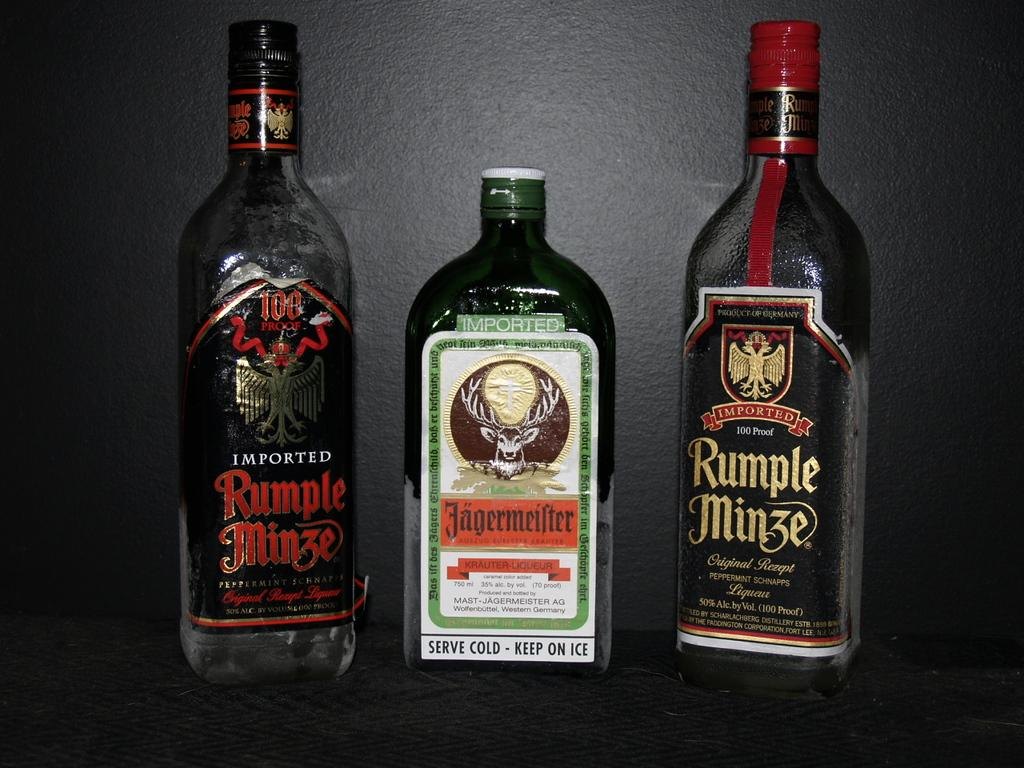<image>
Give a short and clear explanation of the subsequent image. Three bottles of alcohol with two Rumple Minze on the outer part. 